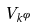Convert formula to latex. <formula><loc_0><loc_0><loc_500><loc_500>V _ { k ^ { \phi } }</formula> 